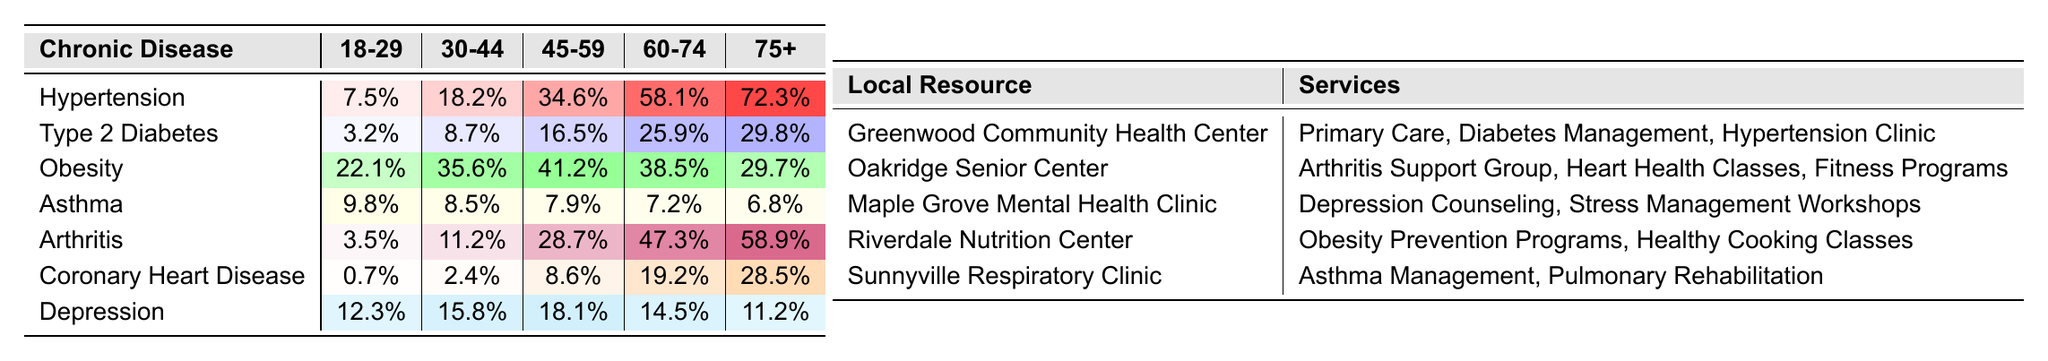What is the prevalence of Hypertension in the age group 60-74? Referring to the table, the value for Hypertension in the age group 60-74 is 58.1%.
Answer: 58.1% Which chronic disease has the highest prevalence in individuals aged 75 and older? By checking the last column for the age group 75+, we see that Hypertension has the highest prevalence at 72.3%.
Answer: Hypertension What is the difference in prevalence of Type 2 Diabetes between age groups 30-44 and 45-59? The prevalence for age group 30-44 is 8.7% and for age group 45-59 is 16.5%. The difference is calculated as 16.5% - 8.7% = 7.8%.
Answer: 7.8% Is the prevalence of Depression higher in the age group 45-59 than in age group 75+? The prevalence for Depression in age group 45-59 is 18.1% and in age group 75+ it is 11.2%. Since 18.1% is greater than 11.2%, the statement is true.
Answer: Yes What is the average prevalence of Obesity across all age groups? To find the average, we sum the prevalences: 22.1% + 35.6% + 41.2% + 38.5% + 29.7% = 167.1%. Then we divide by 5 (the number of age groups), which equals 167.1% / 5 = 33.42%.
Answer: 33.42% How does the prevalence of Asthma change from age group 30-44 to 60-74? The prevalence in age group 30-44 is 8.5% and in age group 60-74 is 7.2%. The change is 7.2% - 8.5% = -1.3%, indicating a decrease.
Answer: Decrease Which age group has the lowest prevalence of Coronary Heart Disease? Looking at the data for Coronary Heart Disease, the age group 18-29 has the lowest prevalence at 0.7%.
Answer: 18-29 Are there any age groups where the prevalence of Arthritis exceeds 50%? By examining the prevalence values for Arthritis, in the age group 60-74 it is 47.3% and in 75+ it is 58.9%. Since 58.9% exceeds 50%, the statement is true.
Answer: Yes What two chronic diseases show a similar pattern of prevalence across age groups? Upon reviewing the data, we see that both Obesity and Type 2 Diabetes start low in the younger age groups and increase with age, although Obesity peaks at 45-59 and then declines.
Answer: Obesity and Type 2 Diabetes What chronic disease has the highest prevalence in the age group 45-59? In the age group 45-59, Hypertension has a prevalence of 34.6%, which is higher than any other chronic disease in that age group.
Answer: Hypertension What is the total prevalence of all chronic diseases in the age group 75+? To find the total prevalence for age group 75+, we sum the values: 72.3% + 29.8% + 29.7% + 6.8% + 58.9% + 28.5% + 11.2% = 236.2%.
Answer: 236.2% 